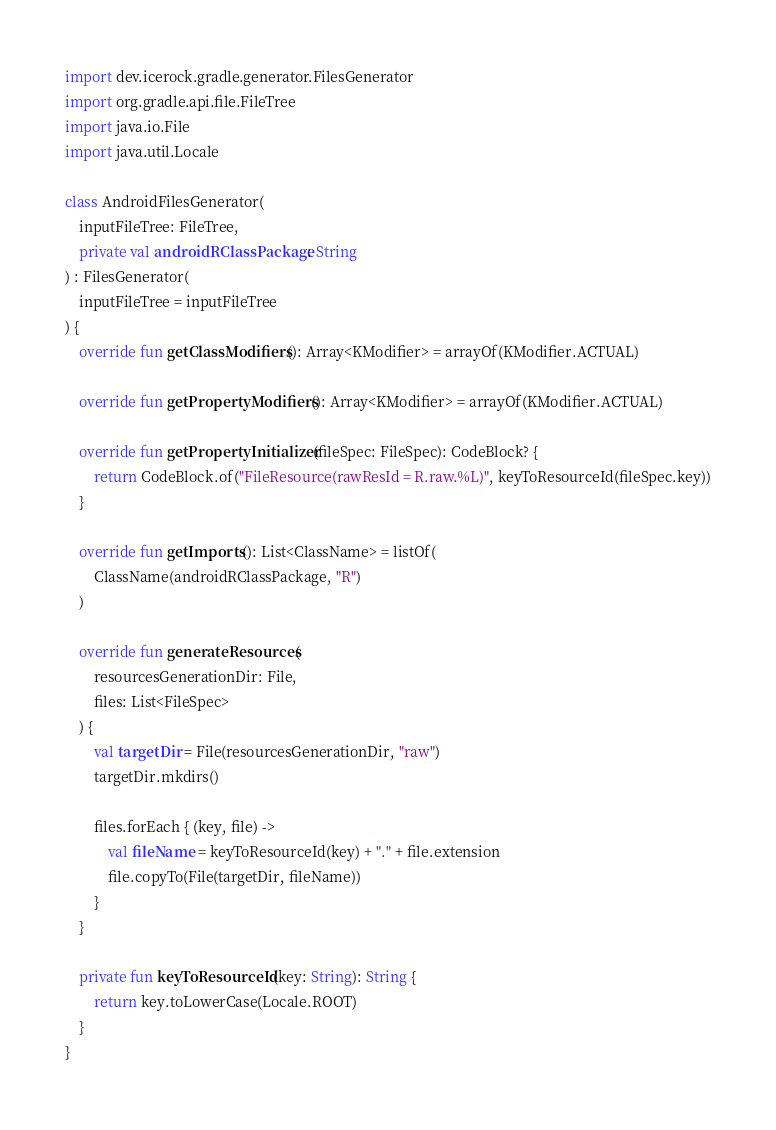<code> <loc_0><loc_0><loc_500><loc_500><_Kotlin_>import dev.icerock.gradle.generator.FilesGenerator
import org.gradle.api.file.FileTree
import java.io.File
import java.util.Locale

class AndroidFilesGenerator(
    inputFileTree: FileTree,
    private val androidRClassPackage: String
) : FilesGenerator(
    inputFileTree = inputFileTree
) {
    override fun getClassModifiers(): Array<KModifier> = arrayOf(KModifier.ACTUAL)

    override fun getPropertyModifiers(): Array<KModifier> = arrayOf(KModifier.ACTUAL)

    override fun getPropertyInitializer(fileSpec: FileSpec): CodeBlock? {
        return CodeBlock.of("FileResource(rawResId = R.raw.%L)", keyToResourceId(fileSpec.key))
    }

    override fun getImports(): List<ClassName> = listOf(
        ClassName(androidRClassPackage, "R")
    )

    override fun generateResources(
        resourcesGenerationDir: File,
        files: List<FileSpec>
    ) {
        val targetDir = File(resourcesGenerationDir, "raw")
        targetDir.mkdirs()

        files.forEach { (key, file) ->
            val fileName = keyToResourceId(key) + "." + file.extension
            file.copyTo(File(targetDir, fileName))
        }
    }

    private fun keyToResourceId(key: String): String {
        return key.toLowerCase(Locale.ROOT)
    }
}
</code> 